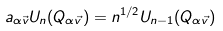<formula> <loc_0><loc_0><loc_500><loc_500>a _ { \alpha \vec { v } } U _ { n } ( Q _ { \alpha \vec { v } } ) = n ^ { 1 / 2 } U _ { n - 1 } ( Q _ { \alpha \vec { v } } )</formula> 